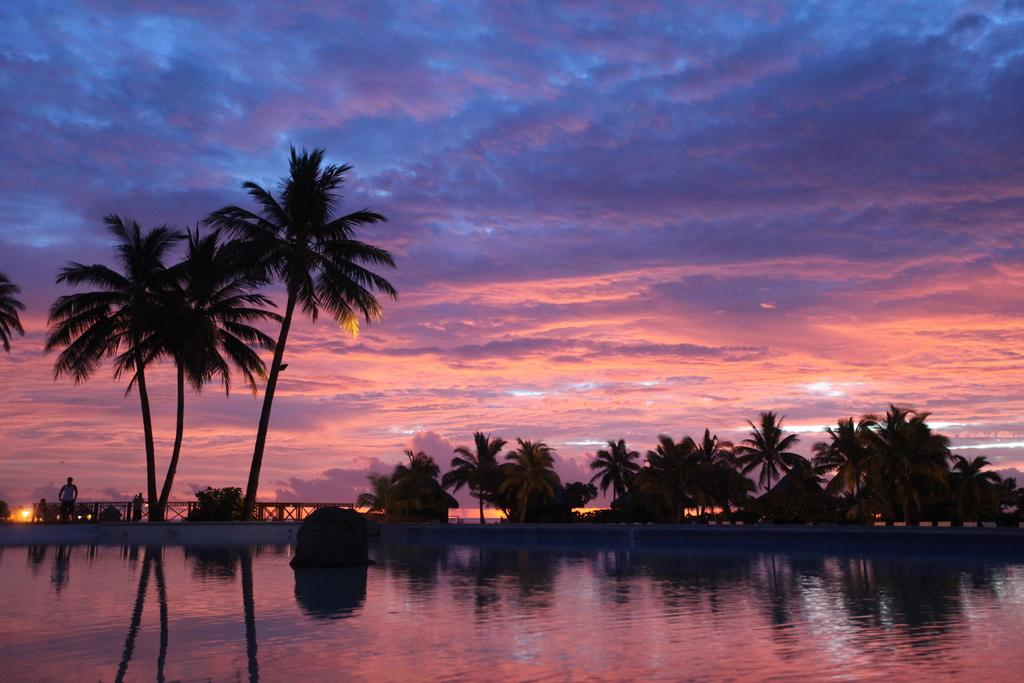What is one of the natural elements present in the image? There is water in the picture. What type of vegetation can be seen in the image? There are trees in the picture. What type of structures are visible in the image? There are huts in the picture. What is the person in the image doing? The person is standing at a fence in the picture. How would you describe the sky in the background? The sky in the background is blue and pink with clouds. What type of education system is being taught in the huts in the image? There is no indication of an education system or any teaching activities in the image; it only shows huts, water, trees, a person, and the sky. 